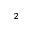<formula> <loc_0><loc_0><loc_500><loc_500>^ { 2 }</formula> 